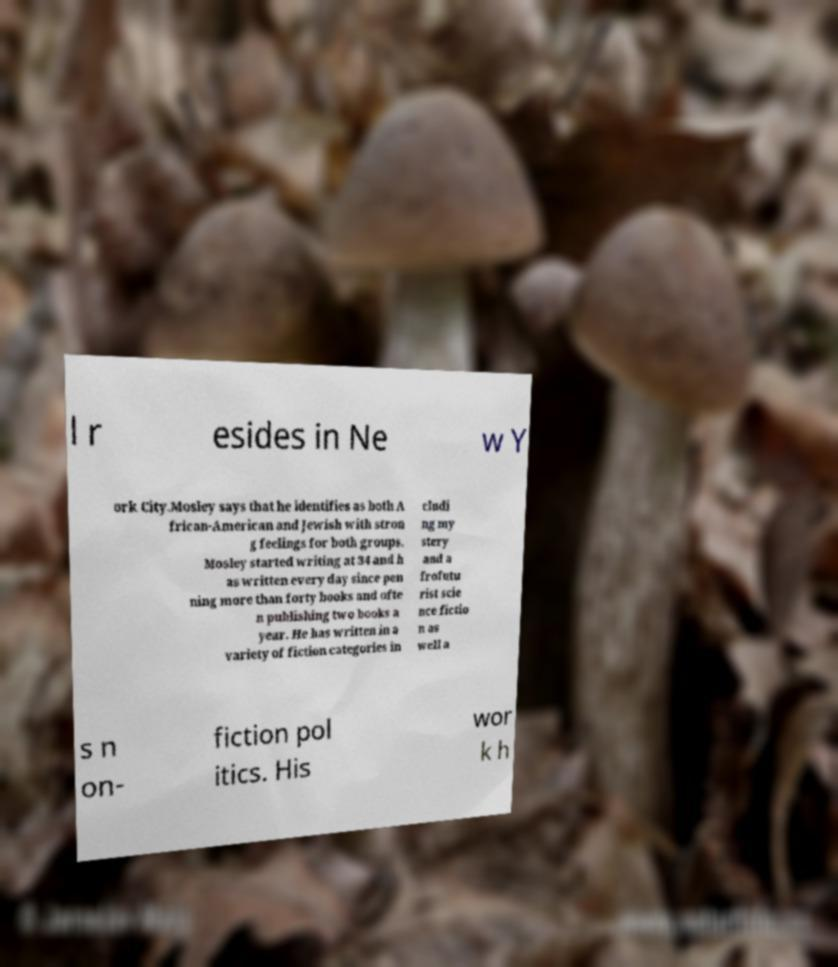There's text embedded in this image that I need extracted. Can you transcribe it verbatim? l r esides in Ne w Y ork City.Mosley says that he identifies as both A frican-American and Jewish with stron g feelings for both groups. Mosley started writing at 34 and h as written every day since pen ning more than forty books and ofte n publishing two books a year. He has written in a variety of fiction categories in cludi ng my stery and a frofutu rist scie nce fictio n as well a s n on- fiction pol itics. His wor k h 